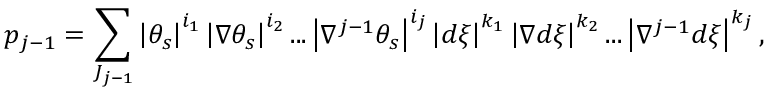Convert formula to latex. <formula><loc_0><loc_0><loc_500><loc_500>p _ { j - 1 } = \sum _ { J _ { j - 1 } } \left | \theta _ { s } \right | ^ { i _ { 1 } } \left | \nabla \theta _ { s } \right | ^ { i _ { 2 } } \dots \left | \nabla ^ { j - 1 } \theta _ { s } \right | ^ { i _ { j } } \left | d \xi \right | ^ { k _ { 1 } } \left | \nabla d \xi \right | ^ { k _ { 2 } } \dots \left | \nabla ^ { j - 1 } d \xi \right | ^ { k _ { j } } ,</formula> 